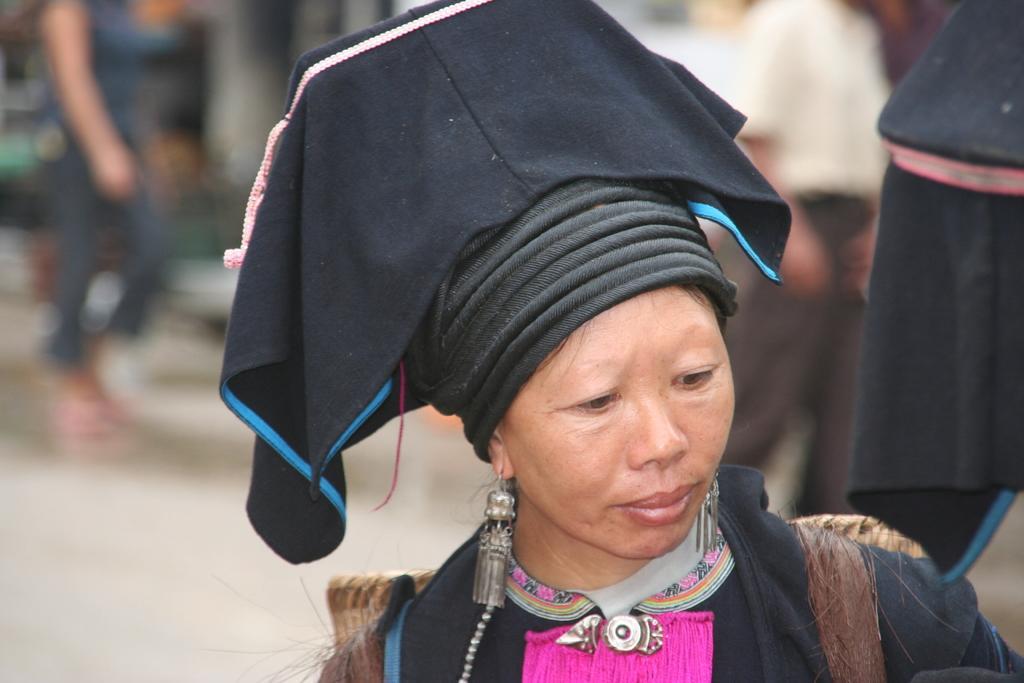Describe this image in one or two sentences. In this image I can see a person wearing black and pink colored dress and black colored hat. I can see the blurry background in which I can see few persons standing on the ground. 